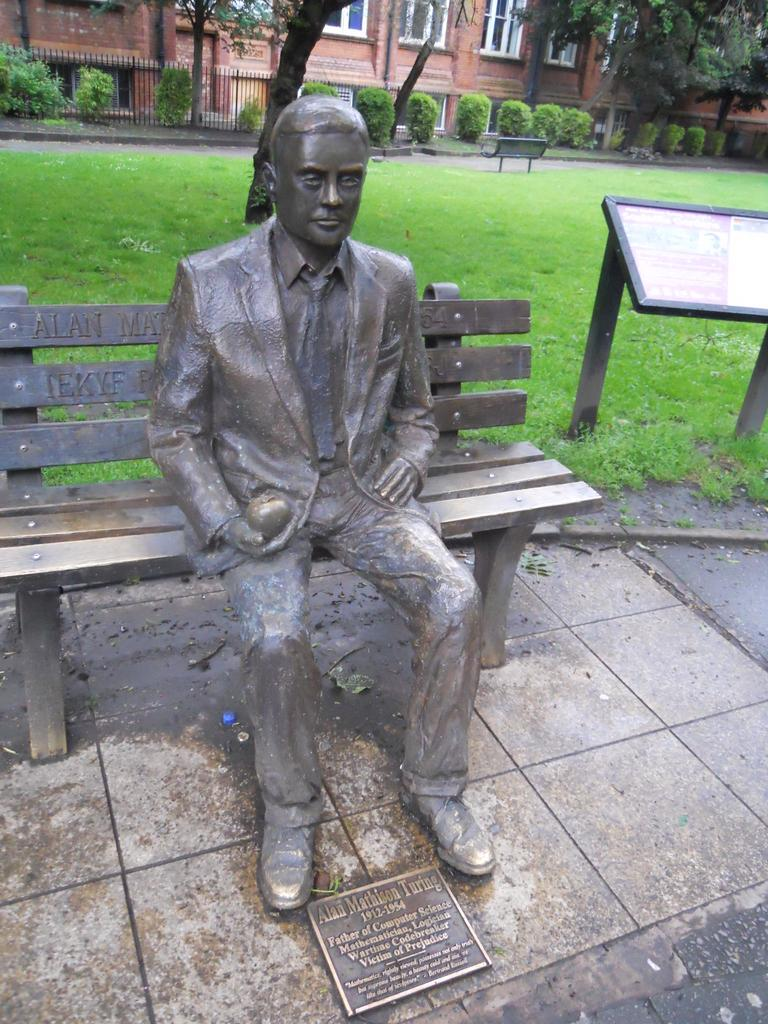What type of structure can be seen in the background of the image? There is a building with windows in the background. What is present in the image that serves as a barrier or boundary? There is a fence in the image. What type of vegetation is visible in the image? There are bushes, trees, and fresh green grass in the image. Can you describe the statue in the image? There is a statue of a man on a bench in the image. What emotion is the statue of the man on the bench displaying in the image? The statue is not capable of displaying emotions, as it is an inanimate object. How many nerves are present in the image? There are no nerves visible in the image, as it is a photograph of a physical scene and not a biological or medical image. 